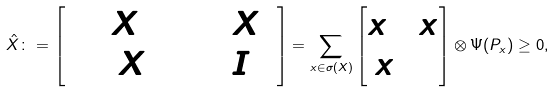<formula> <loc_0><loc_0><loc_500><loc_500>\hat { X } \colon = \begin{bmatrix} \Psi ( X ^ { 2 } ) & \Psi ( X ) \\ \Psi ( X ) & \Psi ( I _ { 1 } ) \end{bmatrix} = \sum _ { x \in \sigma ( X ) } \begin{bmatrix} x ^ { 2 } & x \\ x & 1 \end{bmatrix} \otimes \Psi ( P _ { x } ) \geq 0 ,</formula> 